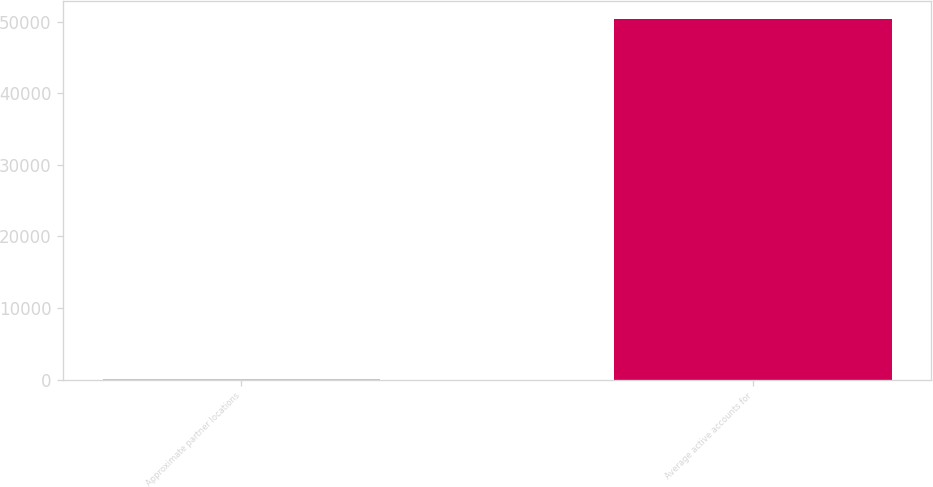<chart> <loc_0><loc_0><loc_500><loc_500><bar_chart><fcel>Approximate partner locations<fcel>Average active accounts for<nl><fcel>40<fcel>50358<nl></chart> 